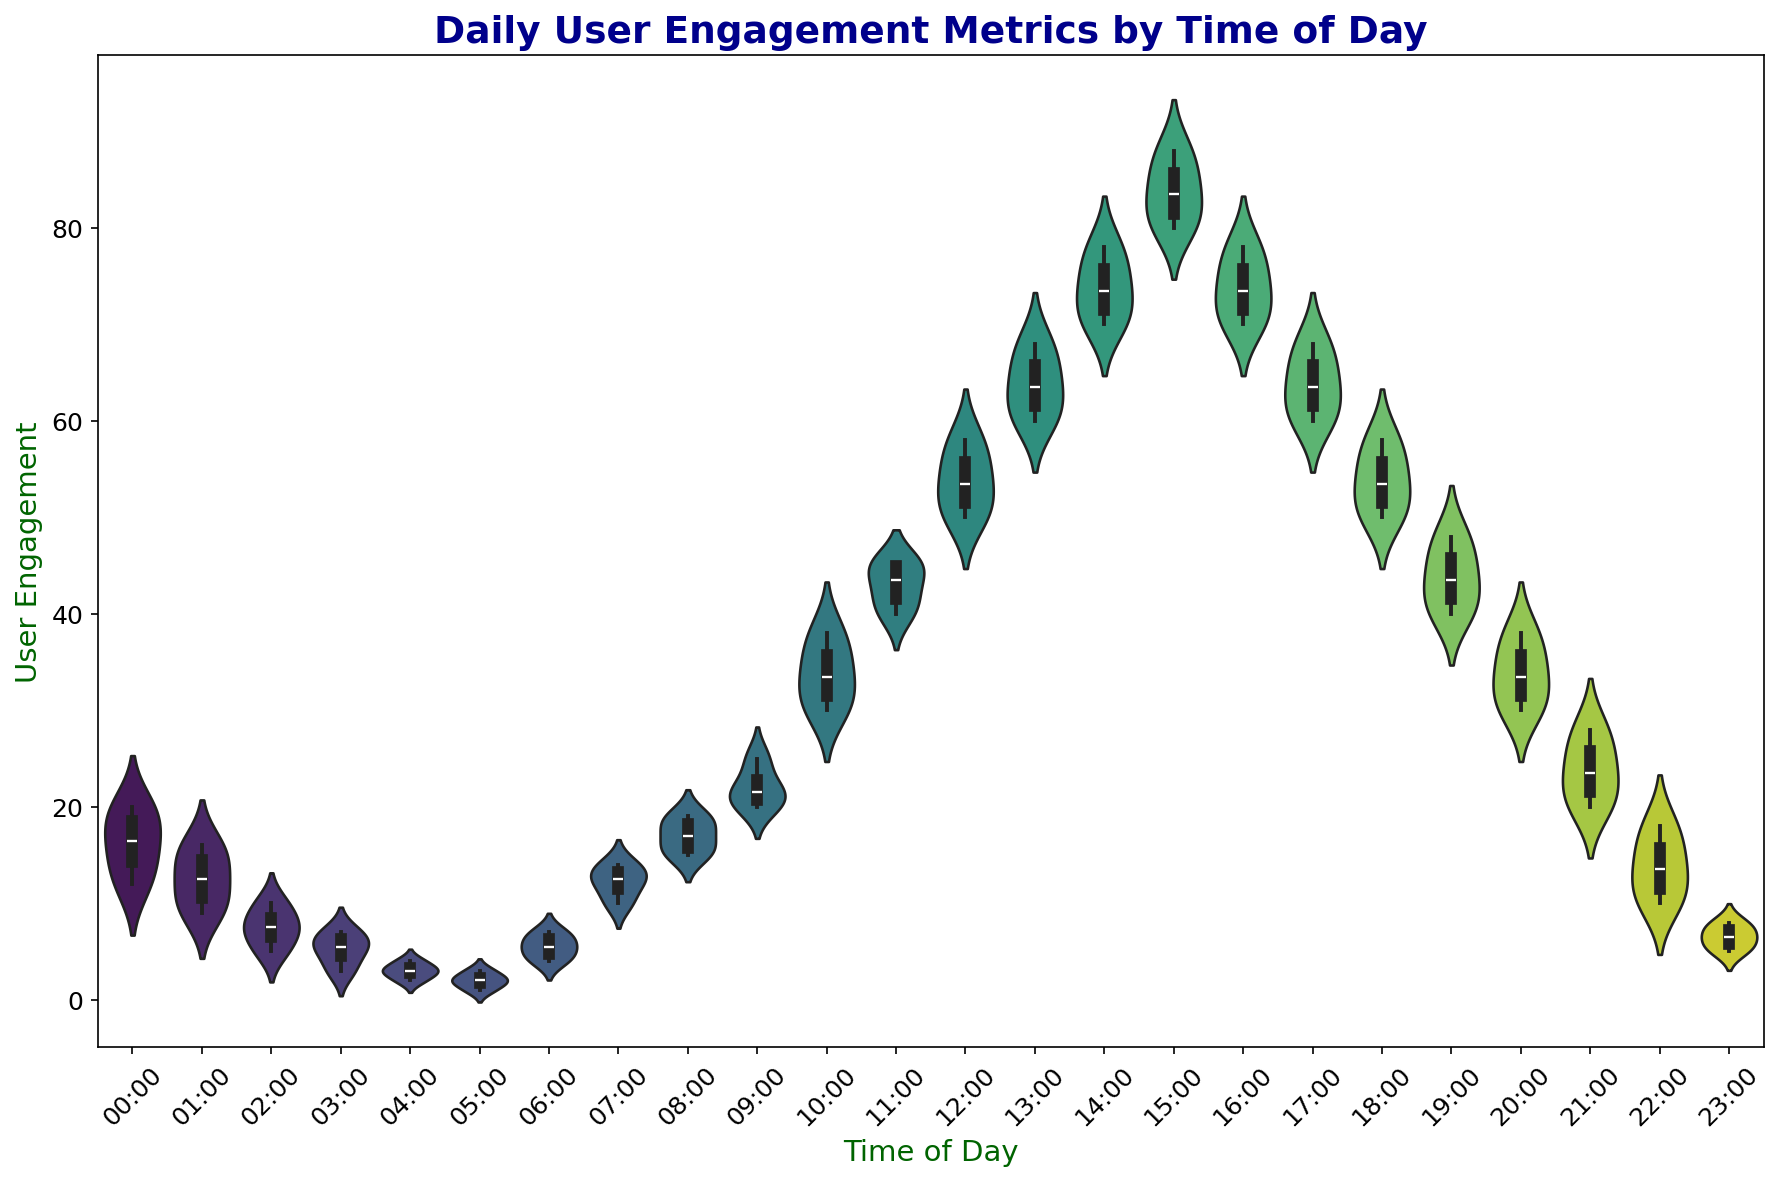what time of day shows the highest median user engagement? The violin plot provides a sense of the median (the thickest part of the violin). The time of day with the highest median would show the highest bulge in the center. Visually, it appears that 15:00 has the highest median user engagement.
Answer: 15:00 around what time do users' engagement metrics start to decrease from the peak? By looking at the violin plot, user engagement falls after reaching a peak. The peak is around 15:00, and engagement begins to decrease after 16:00, which shows a smaller density.
Answer: 16:00 which period shows the most variability in user engagement? Variability in a violin plot can be inferred from the width of the violin. The wider the violin, the more variability in data. The time of day with the widest violin stands around 10:00 to 15:00, indicating the most variability.
Answer: 10:00 to 15:00 how does the user engagement at 12:00 compare with 22:00? The engagement at 12:00 appears significantly higher than at 22:00. Visually, the violin at 12:00 has a higher and larger spread compared to the slender figure at 22:00.
Answer: Engagement is much higher at 12:00 which time has the narrowest range of user engagement values? The narrowest range is represented by the slimmest violin which means less variability. From the plot, the time frame around 04:00 has a very slim figure indicating a narrow range.
Answer: 04:00 what is the average user engagement from 08:00 to 12:00? To find the average, refer to the violin plot segments. For each segment between 08:00 and 12:00, approximate the central values (median) then average them: (16+25+38+45)/4 = 124/4 = 31.
Answer: 31 compare the median user engagement at 06:00 and 18:00. Medians are typically shown by the thickest part of the violin. The median at 18:00 is higher than at 06:00.
Answer: Higher at 18:00 during what hours is the user engagement consistently above 50? The user engagement starts consistently above 50 from 12:00 until 16:00 before it drops again. These violins indicate values consistently above 50.
Answer: 12:00 to 16:00 at what time of day can we observe the lowest user engagement? The lowest user engagement would be represented by the shortest or most compact violin sections. The time at 05:00 has one of the slimmest figures suggesting the lowest engagement.
Answer: 05:00 when is the user engagement likely to be at its lowest variability during the night? To determine low variability (slender violin shape) during the night, we look at hours from 00:00 to 06:00. The smallest violin is at 04:00, indicating the least variability.
Answer: 04:00 